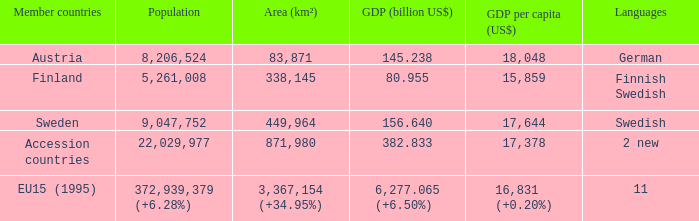Identify the region associated with germany. 83871.0. 